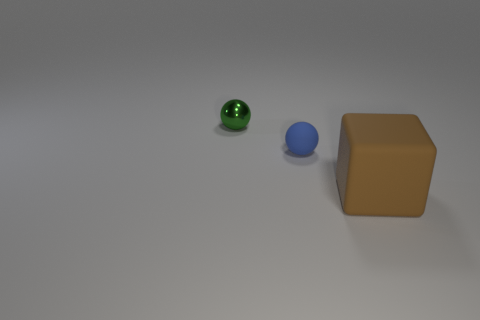Add 3 red rubber cylinders. How many objects exist? 6 Subtract all balls. How many objects are left? 1 Subtract 1 balls. How many balls are left? 1 Subtract all gray blocks. Subtract all cyan balls. How many blocks are left? 1 Subtract all red balls. How many red cubes are left? 0 Subtract all big green rubber cylinders. Subtract all blue things. How many objects are left? 2 Add 1 matte blocks. How many matte blocks are left? 2 Add 1 small purple shiny spheres. How many small purple shiny spheres exist? 1 Subtract all green spheres. How many spheres are left? 1 Subtract 0 red cylinders. How many objects are left? 3 